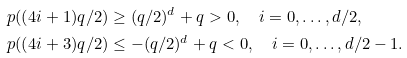<formula> <loc_0><loc_0><loc_500><loc_500>p ( ( 4 i + 1 ) q / 2 ) & \geq ( q / 2 ) ^ { d } + q > 0 , \quad i = 0 , \dots , d / 2 , \\ p ( ( 4 i + 3 ) q / 2 ) & \leq - ( q / 2 ) ^ { d } + q < 0 , \quad i = 0 , \dots , d / 2 - 1 .</formula> 